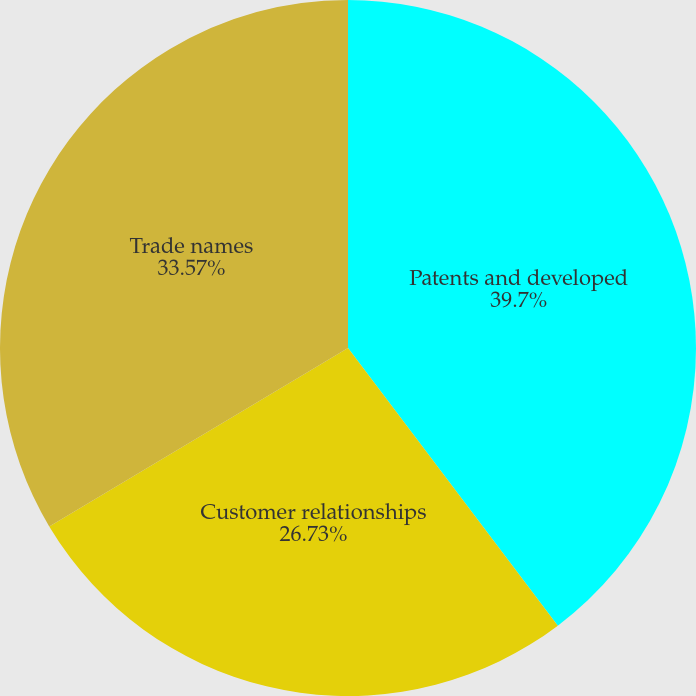Convert chart. <chart><loc_0><loc_0><loc_500><loc_500><pie_chart><fcel>Patents and developed<fcel>Customer relationships<fcel>Trade names<nl><fcel>39.7%<fcel>26.73%<fcel>33.57%<nl></chart> 